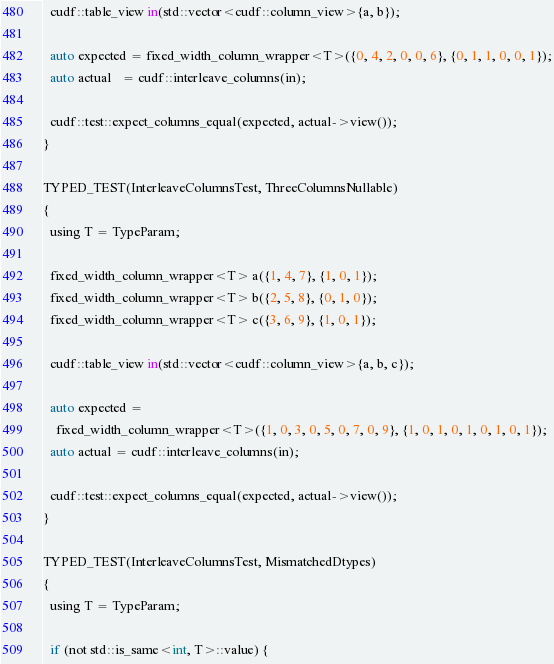Convert code to text. <code><loc_0><loc_0><loc_500><loc_500><_Cuda_>
  cudf::table_view in(std::vector<cudf::column_view>{a, b});

  auto expected = fixed_width_column_wrapper<T>({0, 4, 2, 0, 0, 6}, {0, 1, 1, 0, 0, 1});
  auto actual   = cudf::interleave_columns(in);

  cudf::test::expect_columns_equal(expected, actual->view());
}

TYPED_TEST(InterleaveColumnsTest, ThreeColumnsNullable)
{
  using T = TypeParam;

  fixed_width_column_wrapper<T> a({1, 4, 7}, {1, 0, 1});
  fixed_width_column_wrapper<T> b({2, 5, 8}, {0, 1, 0});
  fixed_width_column_wrapper<T> c({3, 6, 9}, {1, 0, 1});

  cudf::table_view in(std::vector<cudf::column_view>{a, b, c});

  auto expected =
    fixed_width_column_wrapper<T>({1, 0, 3, 0, 5, 0, 7, 0, 9}, {1, 0, 1, 0, 1, 0, 1, 0, 1});
  auto actual = cudf::interleave_columns(in);

  cudf::test::expect_columns_equal(expected, actual->view());
}

TYPED_TEST(InterleaveColumnsTest, MismatchedDtypes)
{
  using T = TypeParam;

  if (not std::is_same<int, T>::value) {</code> 